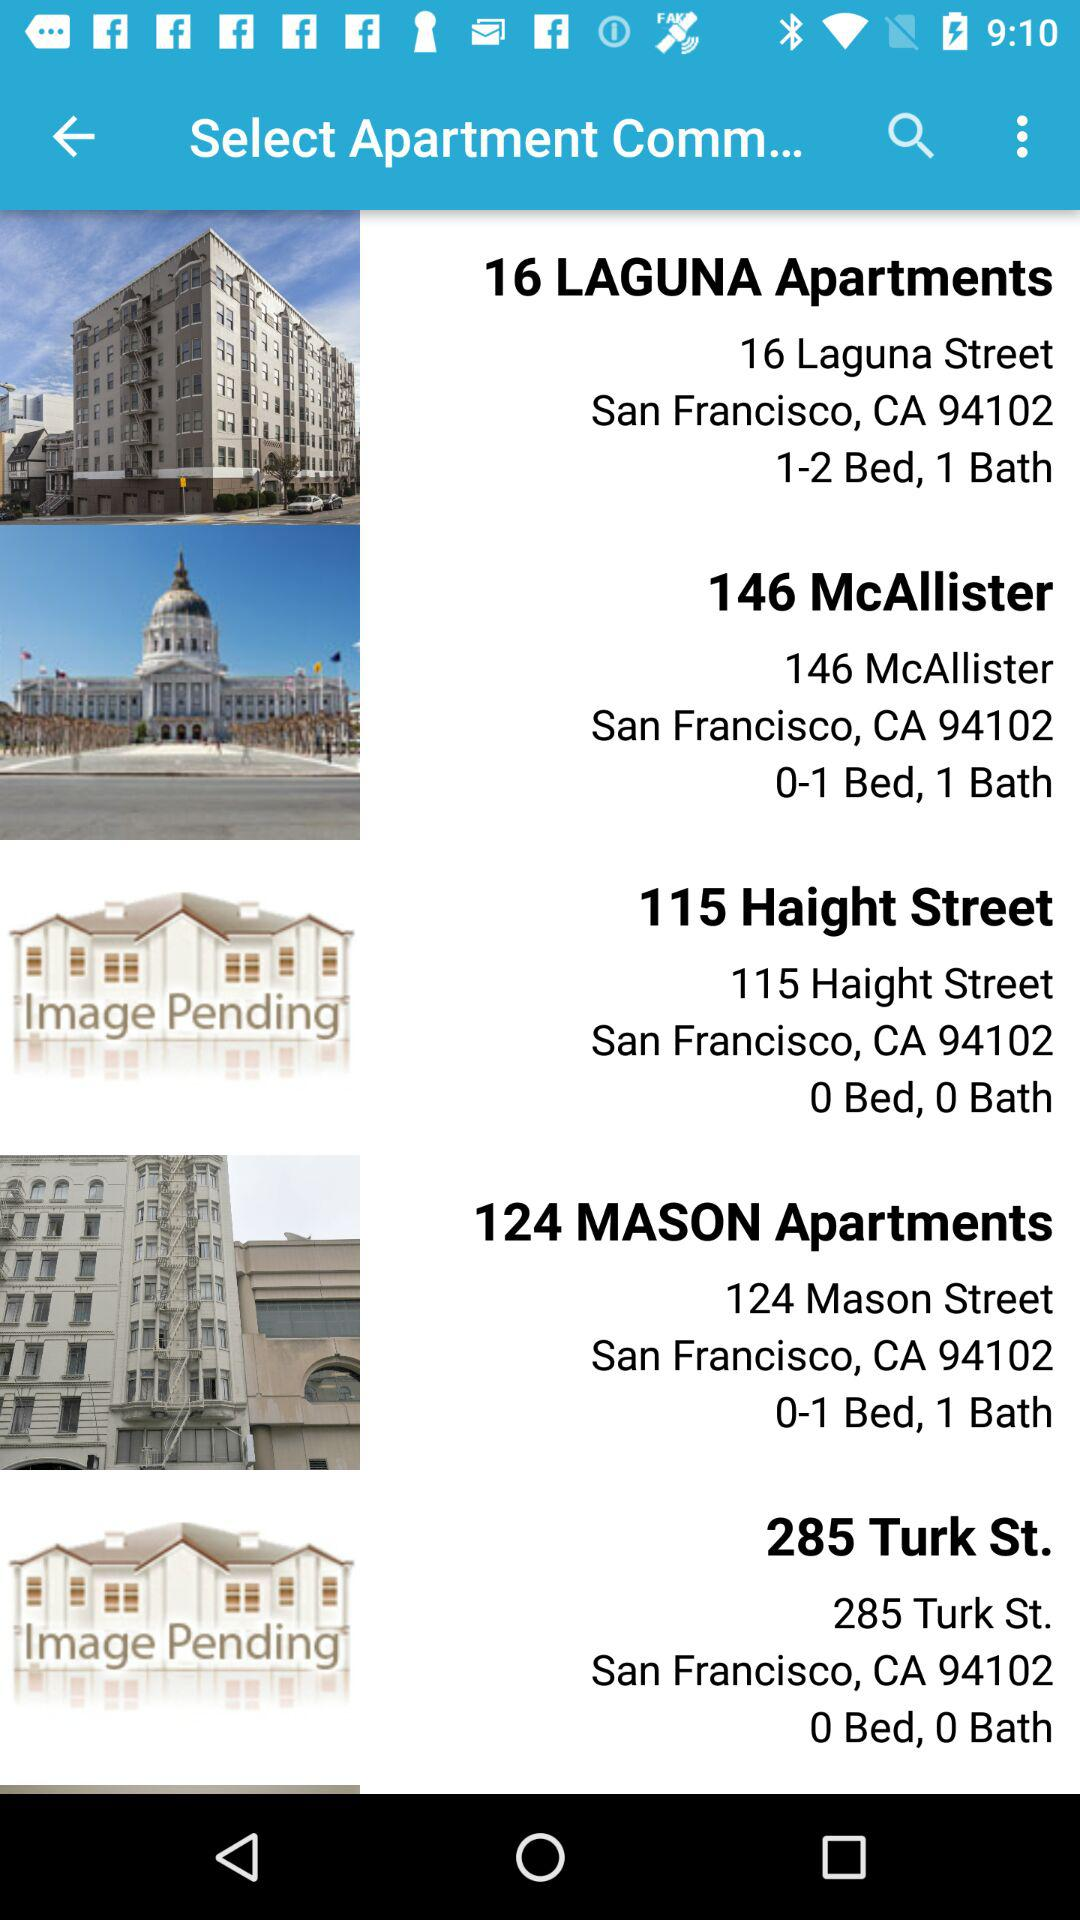What is the address of the "16 LAGUNA Apartments"? The address is 16 Laguna Street San Francisco, CA 94102. 